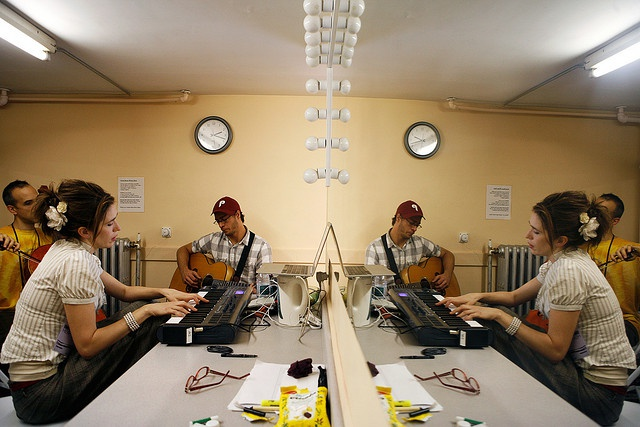Describe the objects in this image and their specific colors. I can see people in black, tan, and maroon tones, people in black, maroon, and tan tones, people in black, maroon, darkgray, and gray tones, people in black, olive, and maroon tones, and people in black, olive, and maroon tones in this image. 